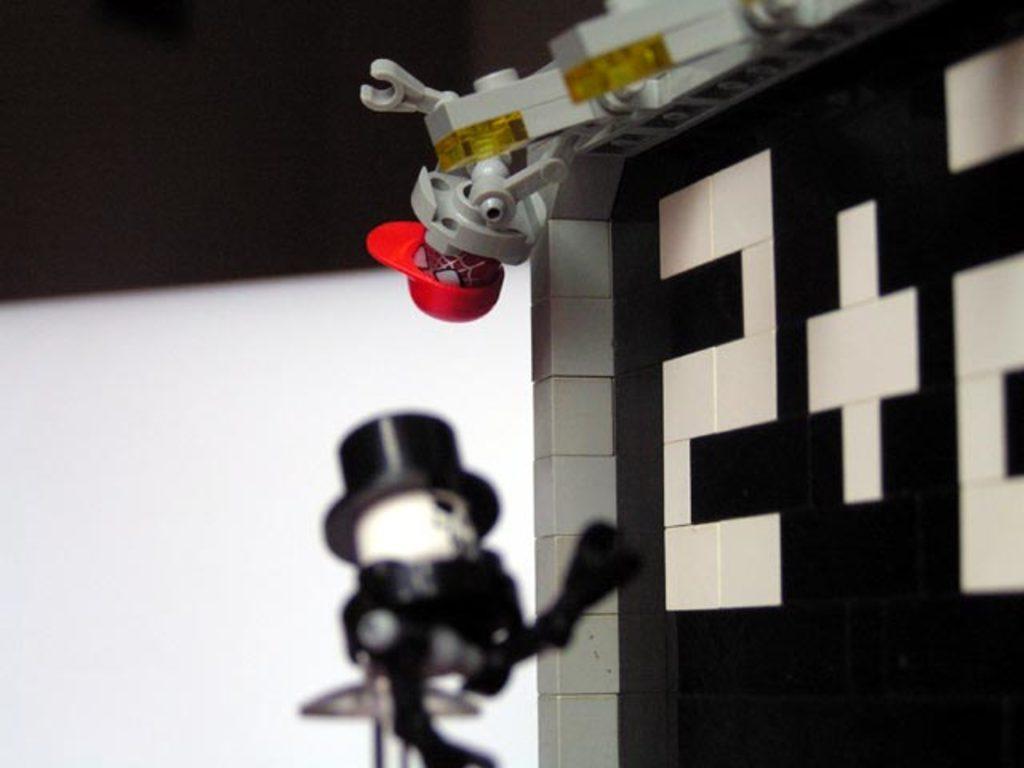In one or two sentences, can you explain what this image depicts? Here in this picture we can see toys present here and there, that are built with the blocks present over there. 